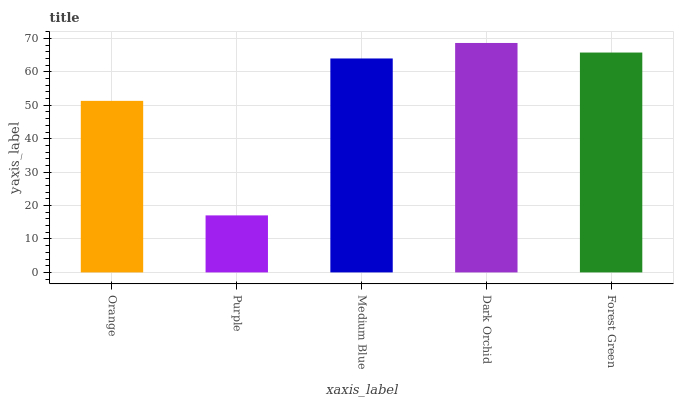Is Purple the minimum?
Answer yes or no. Yes. Is Dark Orchid the maximum?
Answer yes or no. Yes. Is Medium Blue the minimum?
Answer yes or no. No. Is Medium Blue the maximum?
Answer yes or no. No. Is Medium Blue greater than Purple?
Answer yes or no. Yes. Is Purple less than Medium Blue?
Answer yes or no. Yes. Is Purple greater than Medium Blue?
Answer yes or no. No. Is Medium Blue less than Purple?
Answer yes or no. No. Is Medium Blue the high median?
Answer yes or no. Yes. Is Medium Blue the low median?
Answer yes or no. Yes. Is Orange the high median?
Answer yes or no. No. Is Forest Green the low median?
Answer yes or no. No. 